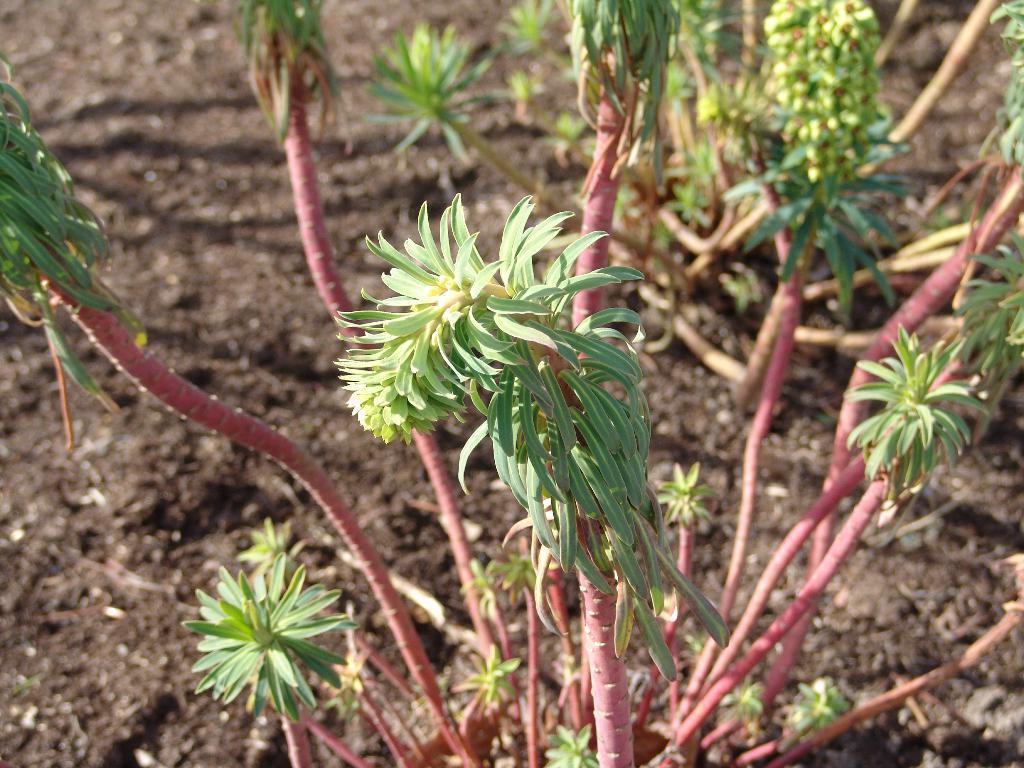How would you summarize this image in a sentence or two? This is the picture of plants with green color leaf and pink color stem in the foreground and with mud at the bottom. 